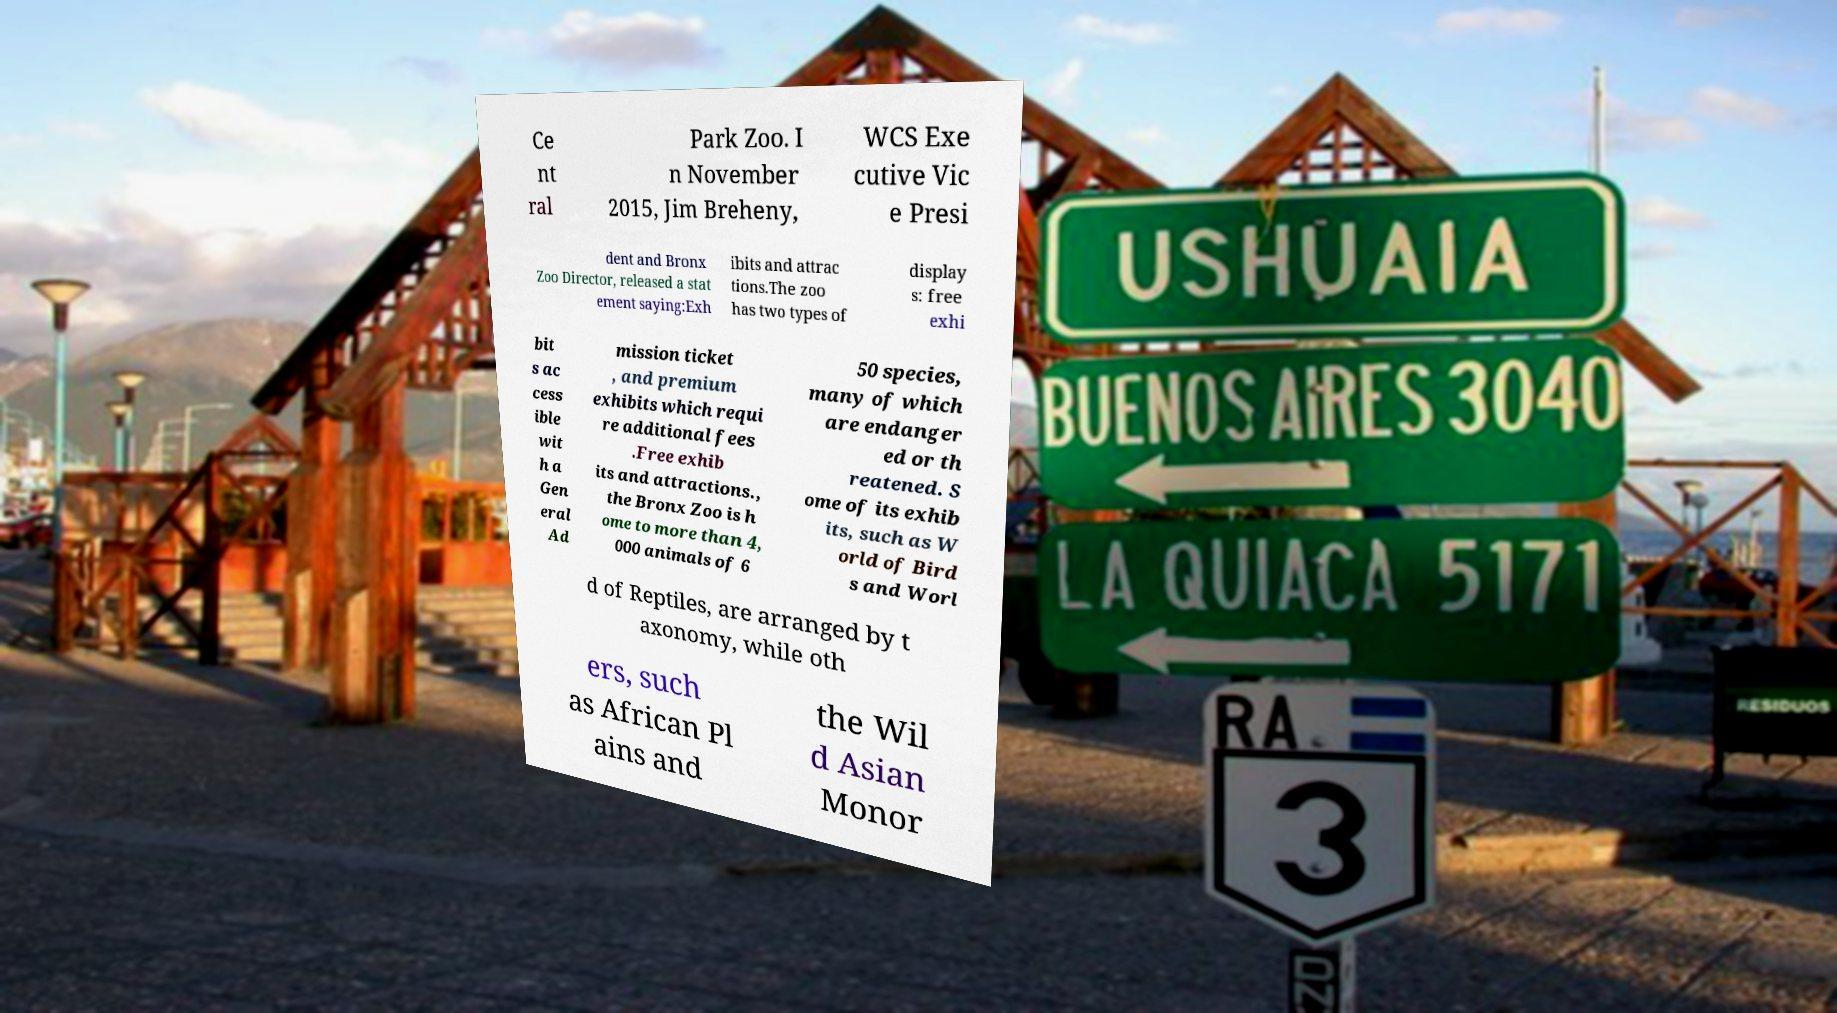Please identify and transcribe the text found in this image. Ce nt ral Park Zoo. I n November 2015, Jim Breheny, WCS Exe cutive Vic e Presi dent and Bronx Zoo Director, released a stat ement saying:Exh ibits and attrac tions.The zoo has two types of display s: free exhi bit s ac cess ible wit h a Gen eral Ad mission ticket , and premium exhibits which requi re additional fees .Free exhib its and attractions., the Bronx Zoo is h ome to more than 4, 000 animals of 6 50 species, many of which are endanger ed or th reatened. S ome of its exhib its, such as W orld of Bird s and Worl d of Reptiles, are arranged by t axonomy, while oth ers, such as African Pl ains and the Wil d Asian Monor 